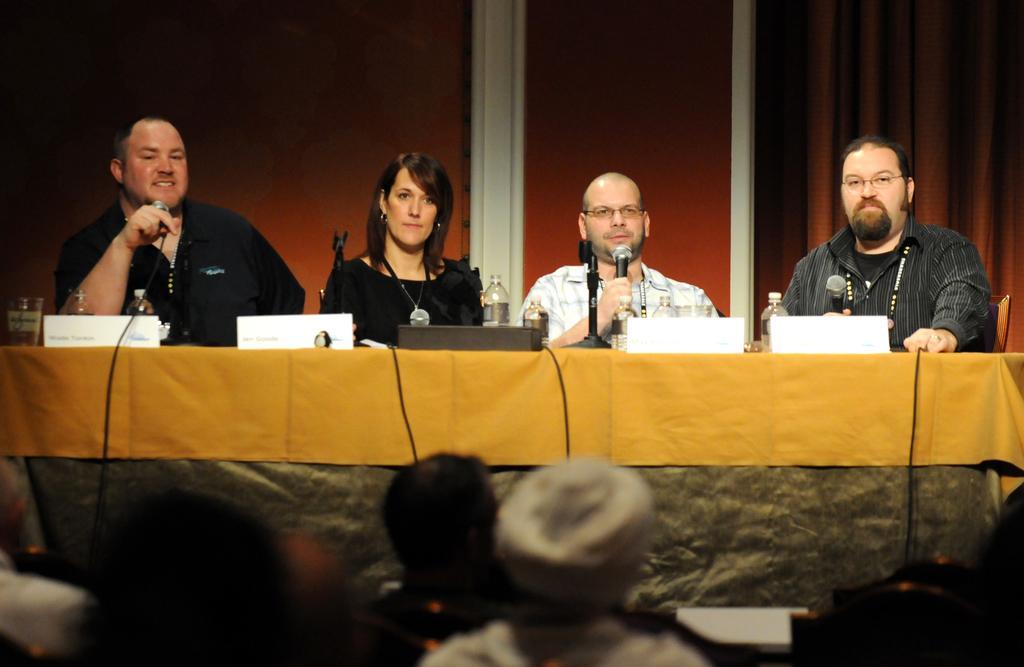How would you summarize this image in a sentence or two? In this Image I see 3 men and a woman who are sitting on chairs and they are in front of a table, on which there are few things. I can also see these 3 men are holding mics, Over here I see few people. 